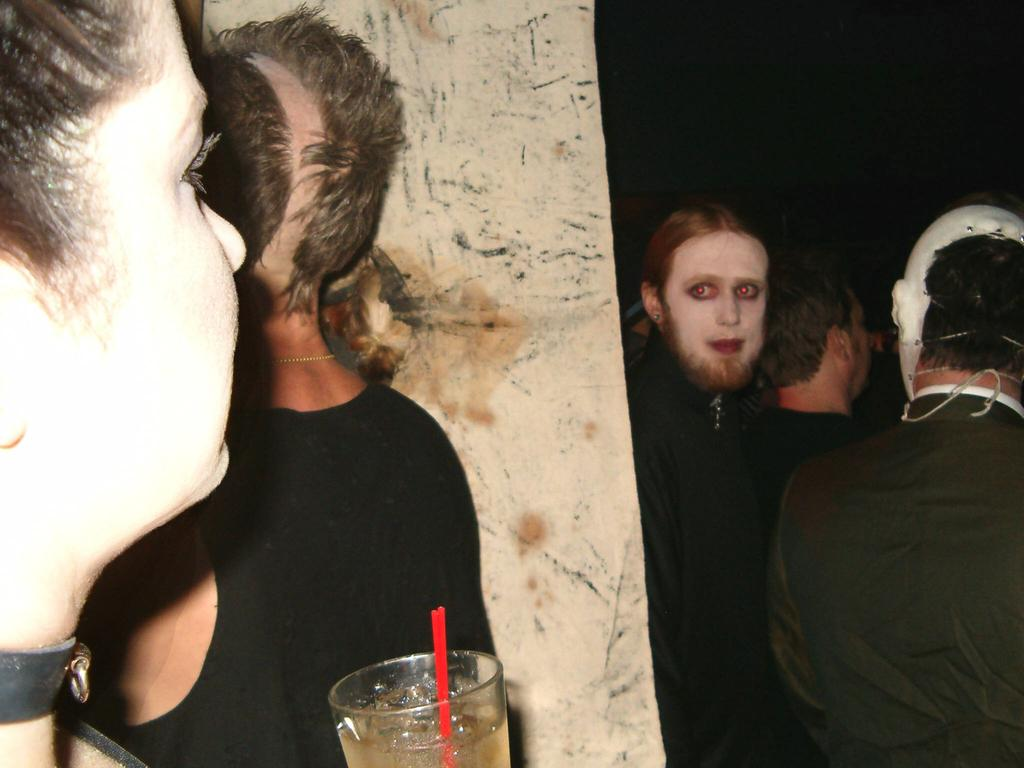What is the person holding in the image? The person is holding a glass in the image. What is inside the glass? The glass contains a straw. Can you describe the people in front of the person holding the glass? There are other people in front of the person holding the glass. What type of gold jewelry can be seen on the person holding the glass? There is no gold jewelry visible on the person holding the glass in the image. 